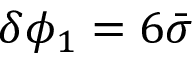Convert formula to latex. <formula><loc_0><loc_0><loc_500><loc_500>\delta \phi _ { 1 } = 6 \bar { \sigma }</formula> 